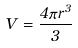<formula> <loc_0><loc_0><loc_500><loc_500>V = \frac { 4 \pi r ^ { 3 } } { 3 }</formula> 